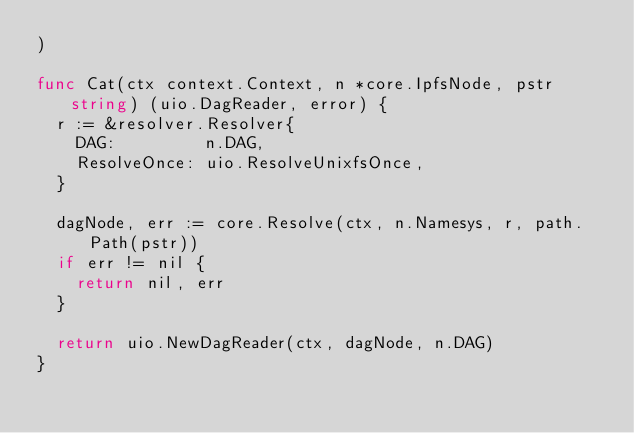<code> <loc_0><loc_0><loc_500><loc_500><_Go_>)

func Cat(ctx context.Context, n *core.IpfsNode, pstr string) (uio.DagReader, error) {
	r := &resolver.Resolver{
		DAG:         n.DAG,
		ResolveOnce: uio.ResolveUnixfsOnce,
	}

	dagNode, err := core.Resolve(ctx, n.Namesys, r, path.Path(pstr))
	if err != nil {
		return nil, err
	}

	return uio.NewDagReader(ctx, dagNode, n.DAG)
}
</code> 